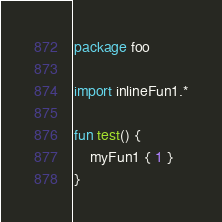Convert code to text. <code><loc_0><loc_0><loc_500><loc_500><_Kotlin_>package foo

import inlineFun1.*

fun test() {
    myFun1 { 1 }
}</code> 